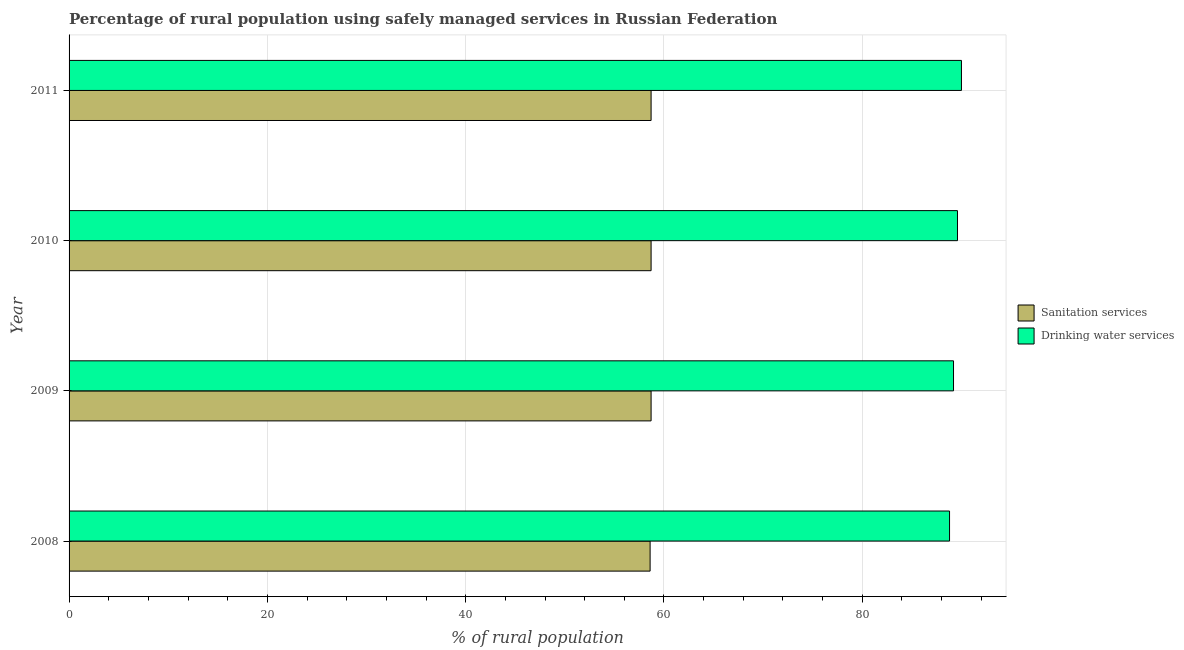How many bars are there on the 1st tick from the top?
Offer a very short reply. 2. What is the percentage of rural population who used sanitation services in 2010?
Your answer should be very brief. 58.7. Across all years, what is the minimum percentage of rural population who used sanitation services?
Keep it short and to the point. 58.6. In which year was the percentage of rural population who used drinking water services minimum?
Your answer should be compact. 2008. What is the total percentage of rural population who used drinking water services in the graph?
Your response must be concise. 357.6. What is the difference between the percentage of rural population who used sanitation services in 2010 and that in 2011?
Ensure brevity in your answer.  0. What is the difference between the percentage of rural population who used sanitation services in 2011 and the percentage of rural population who used drinking water services in 2009?
Ensure brevity in your answer.  -30.5. What is the average percentage of rural population who used drinking water services per year?
Offer a very short reply. 89.4. In the year 2011, what is the difference between the percentage of rural population who used sanitation services and percentage of rural population who used drinking water services?
Make the answer very short. -31.3. In how many years, is the percentage of rural population who used drinking water services greater than 56 %?
Your response must be concise. 4. What is the ratio of the percentage of rural population who used drinking water services in 2008 to that in 2011?
Make the answer very short. 0.99. Is the difference between the percentage of rural population who used drinking water services in 2008 and 2009 greater than the difference between the percentage of rural population who used sanitation services in 2008 and 2009?
Keep it short and to the point. No. What is the difference between the highest and the lowest percentage of rural population who used drinking water services?
Make the answer very short. 1.2. In how many years, is the percentage of rural population who used sanitation services greater than the average percentage of rural population who used sanitation services taken over all years?
Your answer should be compact. 3. What does the 2nd bar from the top in 2011 represents?
Offer a terse response. Sanitation services. What does the 1st bar from the bottom in 2010 represents?
Your answer should be compact. Sanitation services. How many years are there in the graph?
Provide a succinct answer. 4. Does the graph contain grids?
Offer a very short reply. Yes. Where does the legend appear in the graph?
Ensure brevity in your answer.  Center right. What is the title of the graph?
Your answer should be very brief. Percentage of rural population using safely managed services in Russian Federation. Does "Agricultural land" appear as one of the legend labels in the graph?
Give a very brief answer. No. What is the label or title of the X-axis?
Offer a very short reply. % of rural population. What is the label or title of the Y-axis?
Your response must be concise. Year. What is the % of rural population of Sanitation services in 2008?
Keep it short and to the point. 58.6. What is the % of rural population of Drinking water services in 2008?
Provide a succinct answer. 88.8. What is the % of rural population in Sanitation services in 2009?
Give a very brief answer. 58.7. What is the % of rural population in Drinking water services in 2009?
Your response must be concise. 89.2. What is the % of rural population of Sanitation services in 2010?
Provide a succinct answer. 58.7. What is the % of rural population in Drinking water services in 2010?
Keep it short and to the point. 89.6. What is the % of rural population of Sanitation services in 2011?
Keep it short and to the point. 58.7. What is the % of rural population in Drinking water services in 2011?
Your answer should be very brief. 90. Across all years, what is the maximum % of rural population of Sanitation services?
Keep it short and to the point. 58.7. Across all years, what is the maximum % of rural population of Drinking water services?
Offer a terse response. 90. Across all years, what is the minimum % of rural population of Sanitation services?
Offer a very short reply. 58.6. Across all years, what is the minimum % of rural population of Drinking water services?
Your response must be concise. 88.8. What is the total % of rural population of Sanitation services in the graph?
Keep it short and to the point. 234.7. What is the total % of rural population of Drinking water services in the graph?
Your answer should be very brief. 357.6. What is the difference between the % of rural population in Drinking water services in 2008 and that in 2009?
Give a very brief answer. -0.4. What is the difference between the % of rural population of Sanitation services in 2008 and that in 2010?
Ensure brevity in your answer.  -0.1. What is the difference between the % of rural population in Drinking water services in 2008 and that in 2010?
Your response must be concise. -0.8. What is the difference between the % of rural population in Sanitation services in 2008 and that in 2011?
Give a very brief answer. -0.1. What is the difference between the % of rural population of Drinking water services in 2009 and that in 2010?
Your answer should be compact. -0.4. What is the difference between the % of rural population of Drinking water services in 2010 and that in 2011?
Offer a very short reply. -0.4. What is the difference between the % of rural population of Sanitation services in 2008 and the % of rural population of Drinking water services in 2009?
Make the answer very short. -30.6. What is the difference between the % of rural population of Sanitation services in 2008 and the % of rural population of Drinking water services in 2010?
Keep it short and to the point. -31. What is the difference between the % of rural population of Sanitation services in 2008 and the % of rural population of Drinking water services in 2011?
Give a very brief answer. -31.4. What is the difference between the % of rural population in Sanitation services in 2009 and the % of rural population in Drinking water services in 2010?
Ensure brevity in your answer.  -30.9. What is the difference between the % of rural population of Sanitation services in 2009 and the % of rural population of Drinking water services in 2011?
Keep it short and to the point. -31.3. What is the difference between the % of rural population in Sanitation services in 2010 and the % of rural population in Drinking water services in 2011?
Offer a terse response. -31.3. What is the average % of rural population in Sanitation services per year?
Keep it short and to the point. 58.67. What is the average % of rural population in Drinking water services per year?
Offer a very short reply. 89.4. In the year 2008, what is the difference between the % of rural population of Sanitation services and % of rural population of Drinking water services?
Make the answer very short. -30.2. In the year 2009, what is the difference between the % of rural population in Sanitation services and % of rural population in Drinking water services?
Keep it short and to the point. -30.5. In the year 2010, what is the difference between the % of rural population of Sanitation services and % of rural population of Drinking water services?
Give a very brief answer. -30.9. In the year 2011, what is the difference between the % of rural population of Sanitation services and % of rural population of Drinking water services?
Offer a very short reply. -31.3. What is the ratio of the % of rural population of Drinking water services in 2008 to that in 2009?
Your answer should be compact. 1. What is the ratio of the % of rural population of Drinking water services in 2008 to that in 2010?
Provide a short and direct response. 0.99. What is the ratio of the % of rural population in Drinking water services in 2008 to that in 2011?
Your answer should be very brief. 0.99. What is the ratio of the % of rural population in Sanitation services in 2009 to that in 2010?
Give a very brief answer. 1. What is the ratio of the % of rural population in Drinking water services in 2009 to that in 2010?
Your answer should be very brief. 1. What is the ratio of the % of rural population of Sanitation services in 2009 to that in 2011?
Your answer should be very brief. 1. What is the ratio of the % of rural population in Drinking water services in 2009 to that in 2011?
Provide a succinct answer. 0.99. What is the ratio of the % of rural population in Sanitation services in 2010 to that in 2011?
Your answer should be compact. 1. What is the ratio of the % of rural population in Drinking water services in 2010 to that in 2011?
Your response must be concise. 1. What is the difference between the highest and the second highest % of rural population in Sanitation services?
Make the answer very short. 0. 